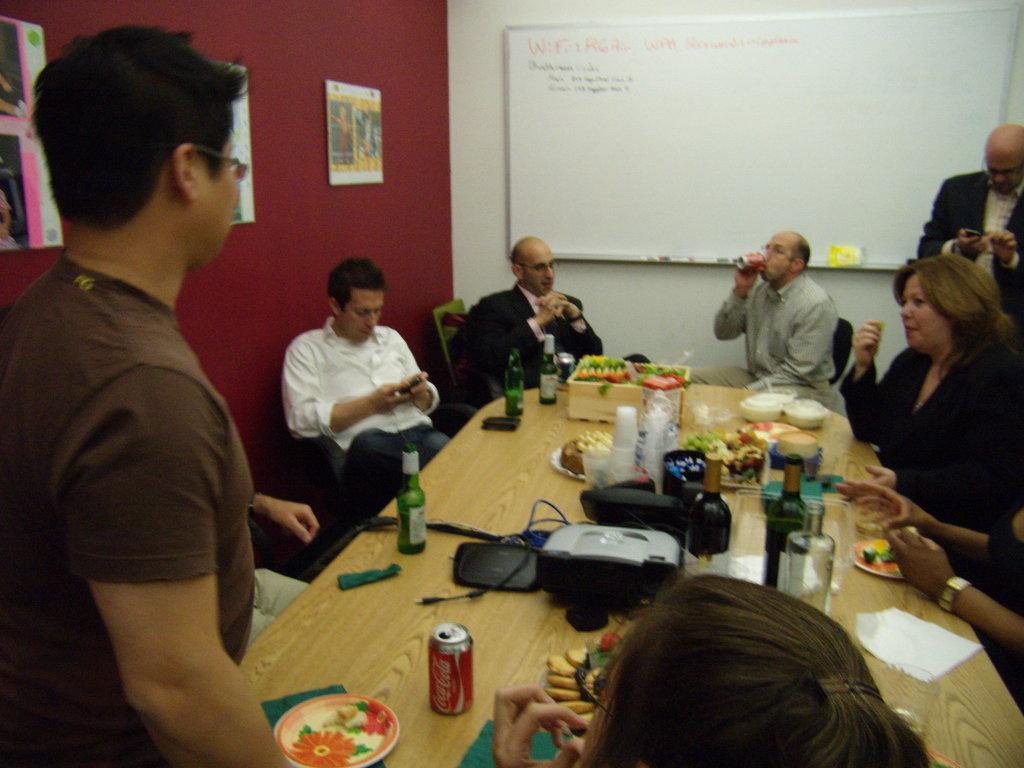Describe this image in one or two sentences. This picture is clicked inside the room. Here, we see many people sitting on the chair and two men standing. In the middle of the picture, we see a table on which a bottle, coke bottle, beer bottle, glass, tiffin box, plate is placed on it. In background, we see the white board on which some text is written. In the right left corner of the picture, we see a wall on which some charts are placed on it. 